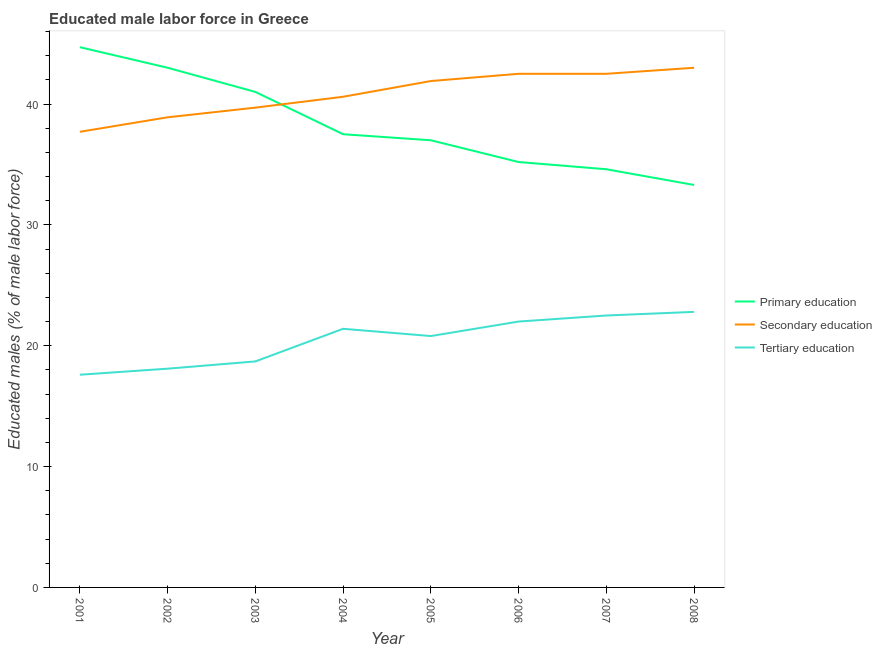What is the percentage of male labor force who received tertiary education in 2008?
Ensure brevity in your answer.  22.8. Across all years, what is the maximum percentage of male labor force who received primary education?
Offer a very short reply. 44.7. Across all years, what is the minimum percentage of male labor force who received primary education?
Your answer should be compact. 33.3. In which year was the percentage of male labor force who received primary education maximum?
Your answer should be compact. 2001. In which year was the percentage of male labor force who received primary education minimum?
Provide a short and direct response. 2008. What is the total percentage of male labor force who received tertiary education in the graph?
Make the answer very short. 163.9. What is the difference between the percentage of male labor force who received secondary education in 2001 and that in 2005?
Make the answer very short. -4.2. What is the average percentage of male labor force who received primary education per year?
Your answer should be compact. 38.29. In how many years, is the percentage of male labor force who received primary education greater than 24 %?
Make the answer very short. 8. What is the ratio of the percentage of male labor force who received secondary education in 2001 to that in 2004?
Provide a succinct answer. 0.93. Is the percentage of male labor force who received secondary education in 2001 less than that in 2008?
Keep it short and to the point. Yes. What is the difference between the highest and the lowest percentage of male labor force who received secondary education?
Provide a short and direct response. 5.3. In how many years, is the percentage of male labor force who received primary education greater than the average percentage of male labor force who received primary education taken over all years?
Make the answer very short. 3. Is the percentage of male labor force who received secondary education strictly greater than the percentage of male labor force who received tertiary education over the years?
Give a very brief answer. Yes. Is the percentage of male labor force who received secondary education strictly less than the percentage of male labor force who received primary education over the years?
Ensure brevity in your answer.  No. How many years are there in the graph?
Make the answer very short. 8. Does the graph contain any zero values?
Your response must be concise. No. How many legend labels are there?
Ensure brevity in your answer.  3. How are the legend labels stacked?
Provide a succinct answer. Vertical. What is the title of the graph?
Offer a terse response. Educated male labor force in Greece. What is the label or title of the X-axis?
Your response must be concise. Year. What is the label or title of the Y-axis?
Your answer should be compact. Educated males (% of male labor force). What is the Educated males (% of male labor force) in Primary education in 2001?
Your answer should be compact. 44.7. What is the Educated males (% of male labor force) in Secondary education in 2001?
Keep it short and to the point. 37.7. What is the Educated males (% of male labor force) of Tertiary education in 2001?
Ensure brevity in your answer.  17.6. What is the Educated males (% of male labor force) of Primary education in 2002?
Your answer should be compact. 43. What is the Educated males (% of male labor force) in Secondary education in 2002?
Provide a succinct answer. 38.9. What is the Educated males (% of male labor force) in Tertiary education in 2002?
Give a very brief answer. 18.1. What is the Educated males (% of male labor force) in Primary education in 2003?
Offer a terse response. 41. What is the Educated males (% of male labor force) in Secondary education in 2003?
Your answer should be very brief. 39.7. What is the Educated males (% of male labor force) of Tertiary education in 2003?
Provide a succinct answer. 18.7. What is the Educated males (% of male labor force) of Primary education in 2004?
Ensure brevity in your answer.  37.5. What is the Educated males (% of male labor force) of Secondary education in 2004?
Keep it short and to the point. 40.6. What is the Educated males (% of male labor force) in Tertiary education in 2004?
Offer a very short reply. 21.4. What is the Educated males (% of male labor force) in Secondary education in 2005?
Make the answer very short. 41.9. What is the Educated males (% of male labor force) in Tertiary education in 2005?
Provide a short and direct response. 20.8. What is the Educated males (% of male labor force) of Primary education in 2006?
Provide a succinct answer. 35.2. What is the Educated males (% of male labor force) in Secondary education in 2006?
Make the answer very short. 42.5. What is the Educated males (% of male labor force) in Primary education in 2007?
Offer a terse response. 34.6. What is the Educated males (% of male labor force) in Secondary education in 2007?
Your answer should be compact. 42.5. What is the Educated males (% of male labor force) of Tertiary education in 2007?
Ensure brevity in your answer.  22.5. What is the Educated males (% of male labor force) of Primary education in 2008?
Provide a short and direct response. 33.3. What is the Educated males (% of male labor force) of Secondary education in 2008?
Offer a terse response. 43. What is the Educated males (% of male labor force) of Tertiary education in 2008?
Offer a very short reply. 22.8. Across all years, what is the maximum Educated males (% of male labor force) of Primary education?
Give a very brief answer. 44.7. Across all years, what is the maximum Educated males (% of male labor force) in Tertiary education?
Your answer should be very brief. 22.8. Across all years, what is the minimum Educated males (% of male labor force) of Primary education?
Provide a succinct answer. 33.3. Across all years, what is the minimum Educated males (% of male labor force) of Secondary education?
Give a very brief answer. 37.7. Across all years, what is the minimum Educated males (% of male labor force) of Tertiary education?
Keep it short and to the point. 17.6. What is the total Educated males (% of male labor force) of Primary education in the graph?
Give a very brief answer. 306.3. What is the total Educated males (% of male labor force) of Secondary education in the graph?
Offer a terse response. 326.8. What is the total Educated males (% of male labor force) in Tertiary education in the graph?
Your answer should be compact. 163.9. What is the difference between the Educated males (% of male labor force) in Primary education in 2001 and that in 2002?
Give a very brief answer. 1.7. What is the difference between the Educated males (% of male labor force) in Secondary education in 2001 and that in 2003?
Give a very brief answer. -2. What is the difference between the Educated males (% of male labor force) of Tertiary education in 2001 and that in 2003?
Offer a terse response. -1.1. What is the difference between the Educated males (% of male labor force) in Primary education in 2001 and that in 2004?
Ensure brevity in your answer.  7.2. What is the difference between the Educated males (% of male labor force) of Secondary education in 2001 and that in 2004?
Give a very brief answer. -2.9. What is the difference between the Educated males (% of male labor force) in Tertiary education in 2001 and that in 2004?
Your answer should be very brief. -3.8. What is the difference between the Educated males (% of male labor force) of Primary education in 2001 and that in 2007?
Your answer should be compact. 10.1. What is the difference between the Educated males (% of male labor force) of Tertiary education in 2001 and that in 2007?
Ensure brevity in your answer.  -4.9. What is the difference between the Educated males (% of male labor force) in Secondary education in 2001 and that in 2008?
Give a very brief answer. -5.3. What is the difference between the Educated males (% of male labor force) in Tertiary education in 2001 and that in 2008?
Keep it short and to the point. -5.2. What is the difference between the Educated males (% of male labor force) in Primary education in 2002 and that in 2003?
Give a very brief answer. 2. What is the difference between the Educated males (% of male labor force) in Secondary education in 2002 and that in 2004?
Offer a very short reply. -1.7. What is the difference between the Educated males (% of male labor force) in Tertiary education in 2002 and that in 2004?
Offer a very short reply. -3.3. What is the difference between the Educated males (% of male labor force) of Primary education in 2002 and that in 2005?
Your answer should be compact. 6. What is the difference between the Educated males (% of male labor force) of Secondary education in 2002 and that in 2006?
Your answer should be compact. -3.6. What is the difference between the Educated males (% of male labor force) of Tertiary education in 2002 and that in 2006?
Your response must be concise. -3.9. What is the difference between the Educated males (% of male labor force) of Primary education in 2002 and that in 2007?
Ensure brevity in your answer.  8.4. What is the difference between the Educated males (% of male labor force) in Secondary education in 2002 and that in 2008?
Ensure brevity in your answer.  -4.1. What is the difference between the Educated males (% of male labor force) in Primary education in 2003 and that in 2005?
Offer a very short reply. 4. What is the difference between the Educated males (% of male labor force) of Secondary education in 2003 and that in 2005?
Offer a very short reply. -2.2. What is the difference between the Educated males (% of male labor force) in Tertiary education in 2003 and that in 2005?
Your answer should be compact. -2.1. What is the difference between the Educated males (% of male labor force) in Tertiary education in 2003 and that in 2006?
Your answer should be very brief. -3.3. What is the difference between the Educated males (% of male labor force) in Primary education in 2003 and that in 2008?
Offer a terse response. 7.7. What is the difference between the Educated males (% of male labor force) of Tertiary education in 2003 and that in 2008?
Provide a short and direct response. -4.1. What is the difference between the Educated males (% of male labor force) in Tertiary education in 2004 and that in 2005?
Provide a short and direct response. 0.6. What is the difference between the Educated males (% of male labor force) in Secondary education in 2004 and that in 2007?
Offer a very short reply. -1.9. What is the difference between the Educated males (% of male labor force) of Tertiary education in 2004 and that in 2007?
Offer a terse response. -1.1. What is the difference between the Educated males (% of male labor force) in Secondary education in 2004 and that in 2008?
Keep it short and to the point. -2.4. What is the difference between the Educated males (% of male labor force) of Primary education in 2005 and that in 2006?
Ensure brevity in your answer.  1.8. What is the difference between the Educated males (% of male labor force) in Tertiary education in 2005 and that in 2006?
Your answer should be very brief. -1.2. What is the difference between the Educated males (% of male labor force) in Primary education in 2005 and that in 2007?
Offer a terse response. 2.4. What is the difference between the Educated males (% of male labor force) in Tertiary education in 2005 and that in 2007?
Offer a very short reply. -1.7. What is the difference between the Educated males (% of male labor force) of Primary education in 2005 and that in 2008?
Keep it short and to the point. 3.7. What is the difference between the Educated males (% of male labor force) in Tertiary education in 2005 and that in 2008?
Your answer should be very brief. -2. What is the difference between the Educated males (% of male labor force) of Primary education in 2006 and that in 2007?
Provide a succinct answer. 0.6. What is the difference between the Educated males (% of male labor force) in Secondary education in 2006 and that in 2008?
Provide a short and direct response. -0.5. What is the difference between the Educated males (% of male labor force) of Primary education in 2007 and that in 2008?
Your answer should be compact. 1.3. What is the difference between the Educated males (% of male labor force) of Tertiary education in 2007 and that in 2008?
Offer a very short reply. -0.3. What is the difference between the Educated males (% of male labor force) in Primary education in 2001 and the Educated males (% of male labor force) in Secondary education in 2002?
Your answer should be compact. 5.8. What is the difference between the Educated males (% of male labor force) in Primary education in 2001 and the Educated males (% of male labor force) in Tertiary education in 2002?
Keep it short and to the point. 26.6. What is the difference between the Educated males (% of male labor force) in Secondary education in 2001 and the Educated males (% of male labor force) in Tertiary education in 2002?
Ensure brevity in your answer.  19.6. What is the difference between the Educated males (% of male labor force) of Primary education in 2001 and the Educated males (% of male labor force) of Tertiary education in 2003?
Offer a terse response. 26. What is the difference between the Educated males (% of male labor force) of Secondary education in 2001 and the Educated males (% of male labor force) of Tertiary education in 2003?
Offer a very short reply. 19. What is the difference between the Educated males (% of male labor force) in Primary education in 2001 and the Educated males (% of male labor force) in Secondary education in 2004?
Provide a succinct answer. 4.1. What is the difference between the Educated males (% of male labor force) in Primary education in 2001 and the Educated males (% of male labor force) in Tertiary education in 2004?
Give a very brief answer. 23.3. What is the difference between the Educated males (% of male labor force) of Primary education in 2001 and the Educated males (% of male labor force) of Secondary education in 2005?
Provide a succinct answer. 2.8. What is the difference between the Educated males (% of male labor force) of Primary education in 2001 and the Educated males (% of male labor force) of Tertiary education in 2005?
Your answer should be compact. 23.9. What is the difference between the Educated males (% of male labor force) of Secondary education in 2001 and the Educated males (% of male labor force) of Tertiary education in 2005?
Offer a terse response. 16.9. What is the difference between the Educated males (% of male labor force) of Primary education in 2001 and the Educated males (% of male labor force) of Secondary education in 2006?
Your answer should be compact. 2.2. What is the difference between the Educated males (% of male labor force) in Primary education in 2001 and the Educated males (% of male labor force) in Tertiary education in 2006?
Your answer should be compact. 22.7. What is the difference between the Educated males (% of male labor force) in Secondary education in 2001 and the Educated males (% of male labor force) in Tertiary education in 2006?
Your response must be concise. 15.7. What is the difference between the Educated males (% of male labor force) of Primary education in 2001 and the Educated males (% of male labor force) of Secondary education in 2007?
Keep it short and to the point. 2.2. What is the difference between the Educated males (% of male labor force) of Primary education in 2001 and the Educated males (% of male labor force) of Tertiary education in 2007?
Offer a very short reply. 22.2. What is the difference between the Educated males (% of male labor force) of Secondary education in 2001 and the Educated males (% of male labor force) of Tertiary education in 2007?
Offer a terse response. 15.2. What is the difference between the Educated males (% of male labor force) of Primary education in 2001 and the Educated males (% of male labor force) of Tertiary education in 2008?
Your answer should be very brief. 21.9. What is the difference between the Educated males (% of male labor force) of Secondary education in 2001 and the Educated males (% of male labor force) of Tertiary education in 2008?
Give a very brief answer. 14.9. What is the difference between the Educated males (% of male labor force) in Primary education in 2002 and the Educated males (% of male labor force) in Tertiary education in 2003?
Keep it short and to the point. 24.3. What is the difference between the Educated males (% of male labor force) in Secondary education in 2002 and the Educated males (% of male labor force) in Tertiary education in 2003?
Offer a very short reply. 20.2. What is the difference between the Educated males (% of male labor force) in Primary education in 2002 and the Educated males (% of male labor force) in Tertiary education in 2004?
Your answer should be very brief. 21.6. What is the difference between the Educated males (% of male labor force) in Secondary education in 2002 and the Educated males (% of male labor force) in Tertiary education in 2004?
Keep it short and to the point. 17.5. What is the difference between the Educated males (% of male labor force) in Primary education in 2002 and the Educated males (% of male labor force) in Secondary education in 2005?
Offer a terse response. 1.1. What is the difference between the Educated males (% of male labor force) of Primary education in 2002 and the Educated males (% of male labor force) of Tertiary education in 2005?
Give a very brief answer. 22.2. What is the difference between the Educated males (% of male labor force) of Primary education in 2002 and the Educated males (% of male labor force) of Secondary education in 2006?
Your answer should be compact. 0.5. What is the difference between the Educated males (% of male labor force) in Primary education in 2002 and the Educated males (% of male labor force) in Tertiary education in 2006?
Your response must be concise. 21. What is the difference between the Educated males (% of male labor force) in Secondary education in 2002 and the Educated males (% of male labor force) in Tertiary education in 2006?
Provide a succinct answer. 16.9. What is the difference between the Educated males (% of male labor force) in Secondary education in 2002 and the Educated males (% of male labor force) in Tertiary education in 2007?
Give a very brief answer. 16.4. What is the difference between the Educated males (% of male labor force) of Primary education in 2002 and the Educated males (% of male labor force) of Tertiary education in 2008?
Make the answer very short. 20.2. What is the difference between the Educated males (% of male labor force) in Secondary education in 2002 and the Educated males (% of male labor force) in Tertiary education in 2008?
Provide a short and direct response. 16.1. What is the difference between the Educated males (% of male labor force) in Primary education in 2003 and the Educated males (% of male labor force) in Secondary education in 2004?
Make the answer very short. 0.4. What is the difference between the Educated males (% of male labor force) in Primary education in 2003 and the Educated males (% of male labor force) in Tertiary education in 2004?
Ensure brevity in your answer.  19.6. What is the difference between the Educated males (% of male labor force) of Primary education in 2003 and the Educated males (% of male labor force) of Secondary education in 2005?
Your answer should be very brief. -0.9. What is the difference between the Educated males (% of male labor force) in Primary education in 2003 and the Educated males (% of male labor force) in Tertiary education in 2005?
Make the answer very short. 20.2. What is the difference between the Educated males (% of male labor force) of Secondary education in 2003 and the Educated males (% of male labor force) of Tertiary education in 2005?
Offer a terse response. 18.9. What is the difference between the Educated males (% of male labor force) in Primary education in 2003 and the Educated males (% of male labor force) in Secondary education in 2006?
Provide a short and direct response. -1.5. What is the difference between the Educated males (% of male labor force) in Primary education in 2003 and the Educated males (% of male labor force) in Tertiary education in 2006?
Make the answer very short. 19. What is the difference between the Educated males (% of male labor force) of Secondary education in 2003 and the Educated males (% of male labor force) of Tertiary education in 2006?
Ensure brevity in your answer.  17.7. What is the difference between the Educated males (% of male labor force) of Primary education in 2003 and the Educated males (% of male labor force) of Secondary education in 2007?
Offer a terse response. -1.5. What is the difference between the Educated males (% of male labor force) of Secondary education in 2003 and the Educated males (% of male labor force) of Tertiary education in 2007?
Give a very brief answer. 17.2. What is the difference between the Educated males (% of male labor force) of Secondary education in 2003 and the Educated males (% of male labor force) of Tertiary education in 2008?
Offer a very short reply. 16.9. What is the difference between the Educated males (% of male labor force) in Primary education in 2004 and the Educated males (% of male labor force) in Secondary education in 2005?
Your answer should be compact. -4.4. What is the difference between the Educated males (% of male labor force) in Primary education in 2004 and the Educated males (% of male labor force) in Tertiary education in 2005?
Your answer should be compact. 16.7. What is the difference between the Educated males (% of male labor force) of Secondary education in 2004 and the Educated males (% of male labor force) of Tertiary education in 2005?
Provide a short and direct response. 19.8. What is the difference between the Educated males (% of male labor force) in Primary education in 2004 and the Educated males (% of male labor force) in Secondary education in 2006?
Give a very brief answer. -5. What is the difference between the Educated males (% of male labor force) in Primary education in 2005 and the Educated males (% of male labor force) in Tertiary education in 2008?
Provide a short and direct response. 14.2. What is the difference between the Educated males (% of male labor force) of Primary education in 2006 and the Educated males (% of male labor force) of Tertiary education in 2007?
Your response must be concise. 12.7. What is the difference between the Educated males (% of male labor force) in Primary education in 2006 and the Educated males (% of male labor force) in Tertiary education in 2008?
Make the answer very short. 12.4. What is the difference between the Educated males (% of male labor force) of Secondary education in 2006 and the Educated males (% of male labor force) of Tertiary education in 2008?
Provide a succinct answer. 19.7. What is the difference between the Educated males (% of male labor force) of Primary education in 2007 and the Educated males (% of male labor force) of Secondary education in 2008?
Ensure brevity in your answer.  -8.4. What is the difference between the Educated males (% of male labor force) in Primary education in 2007 and the Educated males (% of male labor force) in Tertiary education in 2008?
Offer a very short reply. 11.8. What is the difference between the Educated males (% of male labor force) in Secondary education in 2007 and the Educated males (% of male labor force) in Tertiary education in 2008?
Make the answer very short. 19.7. What is the average Educated males (% of male labor force) of Primary education per year?
Provide a succinct answer. 38.29. What is the average Educated males (% of male labor force) of Secondary education per year?
Your answer should be compact. 40.85. What is the average Educated males (% of male labor force) in Tertiary education per year?
Your response must be concise. 20.49. In the year 2001, what is the difference between the Educated males (% of male labor force) in Primary education and Educated males (% of male labor force) in Tertiary education?
Keep it short and to the point. 27.1. In the year 2001, what is the difference between the Educated males (% of male labor force) in Secondary education and Educated males (% of male labor force) in Tertiary education?
Offer a very short reply. 20.1. In the year 2002, what is the difference between the Educated males (% of male labor force) in Primary education and Educated males (% of male labor force) in Tertiary education?
Ensure brevity in your answer.  24.9. In the year 2002, what is the difference between the Educated males (% of male labor force) in Secondary education and Educated males (% of male labor force) in Tertiary education?
Provide a succinct answer. 20.8. In the year 2003, what is the difference between the Educated males (% of male labor force) in Primary education and Educated males (% of male labor force) in Secondary education?
Offer a terse response. 1.3. In the year 2003, what is the difference between the Educated males (% of male labor force) of Primary education and Educated males (% of male labor force) of Tertiary education?
Your answer should be compact. 22.3. In the year 2003, what is the difference between the Educated males (% of male labor force) in Secondary education and Educated males (% of male labor force) in Tertiary education?
Offer a terse response. 21. In the year 2004, what is the difference between the Educated males (% of male labor force) in Primary education and Educated males (% of male labor force) in Tertiary education?
Provide a succinct answer. 16.1. In the year 2005, what is the difference between the Educated males (% of male labor force) in Primary education and Educated males (% of male labor force) in Secondary education?
Keep it short and to the point. -4.9. In the year 2005, what is the difference between the Educated males (% of male labor force) in Primary education and Educated males (% of male labor force) in Tertiary education?
Make the answer very short. 16.2. In the year 2005, what is the difference between the Educated males (% of male labor force) of Secondary education and Educated males (% of male labor force) of Tertiary education?
Your response must be concise. 21.1. In the year 2006, what is the difference between the Educated males (% of male labor force) of Primary education and Educated males (% of male labor force) of Secondary education?
Provide a short and direct response. -7.3. In the year 2006, what is the difference between the Educated males (% of male labor force) of Primary education and Educated males (% of male labor force) of Tertiary education?
Give a very brief answer. 13.2. In the year 2006, what is the difference between the Educated males (% of male labor force) in Secondary education and Educated males (% of male labor force) in Tertiary education?
Your answer should be very brief. 20.5. In the year 2007, what is the difference between the Educated males (% of male labor force) of Primary education and Educated males (% of male labor force) of Secondary education?
Offer a terse response. -7.9. In the year 2007, what is the difference between the Educated males (% of male labor force) of Primary education and Educated males (% of male labor force) of Tertiary education?
Your answer should be very brief. 12.1. In the year 2008, what is the difference between the Educated males (% of male labor force) in Primary education and Educated males (% of male labor force) in Tertiary education?
Give a very brief answer. 10.5. In the year 2008, what is the difference between the Educated males (% of male labor force) of Secondary education and Educated males (% of male labor force) of Tertiary education?
Ensure brevity in your answer.  20.2. What is the ratio of the Educated males (% of male labor force) of Primary education in 2001 to that in 2002?
Offer a very short reply. 1.04. What is the ratio of the Educated males (% of male labor force) of Secondary education in 2001 to that in 2002?
Give a very brief answer. 0.97. What is the ratio of the Educated males (% of male labor force) in Tertiary education in 2001 to that in 2002?
Offer a terse response. 0.97. What is the ratio of the Educated males (% of male labor force) of Primary education in 2001 to that in 2003?
Offer a terse response. 1.09. What is the ratio of the Educated males (% of male labor force) of Secondary education in 2001 to that in 2003?
Provide a short and direct response. 0.95. What is the ratio of the Educated males (% of male labor force) of Primary education in 2001 to that in 2004?
Your answer should be very brief. 1.19. What is the ratio of the Educated males (% of male labor force) of Secondary education in 2001 to that in 2004?
Keep it short and to the point. 0.93. What is the ratio of the Educated males (% of male labor force) in Tertiary education in 2001 to that in 2004?
Provide a short and direct response. 0.82. What is the ratio of the Educated males (% of male labor force) of Primary education in 2001 to that in 2005?
Ensure brevity in your answer.  1.21. What is the ratio of the Educated males (% of male labor force) of Secondary education in 2001 to that in 2005?
Provide a short and direct response. 0.9. What is the ratio of the Educated males (% of male labor force) in Tertiary education in 2001 to that in 2005?
Offer a terse response. 0.85. What is the ratio of the Educated males (% of male labor force) in Primary education in 2001 to that in 2006?
Give a very brief answer. 1.27. What is the ratio of the Educated males (% of male labor force) of Secondary education in 2001 to that in 2006?
Provide a short and direct response. 0.89. What is the ratio of the Educated males (% of male labor force) of Tertiary education in 2001 to that in 2006?
Provide a short and direct response. 0.8. What is the ratio of the Educated males (% of male labor force) in Primary education in 2001 to that in 2007?
Keep it short and to the point. 1.29. What is the ratio of the Educated males (% of male labor force) of Secondary education in 2001 to that in 2007?
Ensure brevity in your answer.  0.89. What is the ratio of the Educated males (% of male labor force) in Tertiary education in 2001 to that in 2007?
Offer a very short reply. 0.78. What is the ratio of the Educated males (% of male labor force) in Primary education in 2001 to that in 2008?
Offer a terse response. 1.34. What is the ratio of the Educated males (% of male labor force) in Secondary education in 2001 to that in 2008?
Provide a short and direct response. 0.88. What is the ratio of the Educated males (% of male labor force) of Tertiary education in 2001 to that in 2008?
Give a very brief answer. 0.77. What is the ratio of the Educated males (% of male labor force) of Primary education in 2002 to that in 2003?
Your answer should be very brief. 1.05. What is the ratio of the Educated males (% of male labor force) of Secondary education in 2002 to that in 2003?
Give a very brief answer. 0.98. What is the ratio of the Educated males (% of male labor force) of Tertiary education in 2002 to that in 2003?
Offer a very short reply. 0.97. What is the ratio of the Educated males (% of male labor force) of Primary education in 2002 to that in 2004?
Give a very brief answer. 1.15. What is the ratio of the Educated males (% of male labor force) in Secondary education in 2002 to that in 2004?
Your response must be concise. 0.96. What is the ratio of the Educated males (% of male labor force) of Tertiary education in 2002 to that in 2004?
Offer a very short reply. 0.85. What is the ratio of the Educated males (% of male labor force) in Primary education in 2002 to that in 2005?
Make the answer very short. 1.16. What is the ratio of the Educated males (% of male labor force) in Secondary education in 2002 to that in 2005?
Make the answer very short. 0.93. What is the ratio of the Educated males (% of male labor force) in Tertiary education in 2002 to that in 2005?
Ensure brevity in your answer.  0.87. What is the ratio of the Educated males (% of male labor force) of Primary education in 2002 to that in 2006?
Give a very brief answer. 1.22. What is the ratio of the Educated males (% of male labor force) of Secondary education in 2002 to that in 2006?
Offer a terse response. 0.92. What is the ratio of the Educated males (% of male labor force) of Tertiary education in 2002 to that in 2006?
Offer a terse response. 0.82. What is the ratio of the Educated males (% of male labor force) in Primary education in 2002 to that in 2007?
Your answer should be very brief. 1.24. What is the ratio of the Educated males (% of male labor force) of Secondary education in 2002 to that in 2007?
Provide a short and direct response. 0.92. What is the ratio of the Educated males (% of male labor force) in Tertiary education in 2002 to that in 2007?
Your answer should be very brief. 0.8. What is the ratio of the Educated males (% of male labor force) in Primary education in 2002 to that in 2008?
Offer a terse response. 1.29. What is the ratio of the Educated males (% of male labor force) of Secondary education in 2002 to that in 2008?
Make the answer very short. 0.9. What is the ratio of the Educated males (% of male labor force) of Tertiary education in 2002 to that in 2008?
Your answer should be very brief. 0.79. What is the ratio of the Educated males (% of male labor force) of Primary education in 2003 to that in 2004?
Your answer should be compact. 1.09. What is the ratio of the Educated males (% of male labor force) in Secondary education in 2003 to that in 2004?
Ensure brevity in your answer.  0.98. What is the ratio of the Educated males (% of male labor force) in Tertiary education in 2003 to that in 2004?
Your answer should be compact. 0.87. What is the ratio of the Educated males (% of male labor force) of Primary education in 2003 to that in 2005?
Provide a short and direct response. 1.11. What is the ratio of the Educated males (% of male labor force) of Secondary education in 2003 to that in 2005?
Make the answer very short. 0.95. What is the ratio of the Educated males (% of male labor force) in Tertiary education in 2003 to that in 2005?
Your answer should be very brief. 0.9. What is the ratio of the Educated males (% of male labor force) of Primary education in 2003 to that in 2006?
Keep it short and to the point. 1.16. What is the ratio of the Educated males (% of male labor force) in Secondary education in 2003 to that in 2006?
Keep it short and to the point. 0.93. What is the ratio of the Educated males (% of male labor force) in Tertiary education in 2003 to that in 2006?
Provide a succinct answer. 0.85. What is the ratio of the Educated males (% of male labor force) of Primary education in 2003 to that in 2007?
Give a very brief answer. 1.19. What is the ratio of the Educated males (% of male labor force) in Secondary education in 2003 to that in 2007?
Your response must be concise. 0.93. What is the ratio of the Educated males (% of male labor force) of Tertiary education in 2003 to that in 2007?
Provide a short and direct response. 0.83. What is the ratio of the Educated males (% of male labor force) of Primary education in 2003 to that in 2008?
Give a very brief answer. 1.23. What is the ratio of the Educated males (% of male labor force) in Secondary education in 2003 to that in 2008?
Offer a terse response. 0.92. What is the ratio of the Educated males (% of male labor force) in Tertiary education in 2003 to that in 2008?
Provide a short and direct response. 0.82. What is the ratio of the Educated males (% of male labor force) in Primary education in 2004 to that in 2005?
Your answer should be very brief. 1.01. What is the ratio of the Educated males (% of male labor force) in Tertiary education in 2004 to that in 2005?
Your answer should be compact. 1.03. What is the ratio of the Educated males (% of male labor force) in Primary education in 2004 to that in 2006?
Offer a very short reply. 1.07. What is the ratio of the Educated males (% of male labor force) of Secondary education in 2004 to that in 2006?
Offer a very short reply. 0.96. What is the ratio of the Educated males (% of male labor force) in Tertiary education in 2004 to that in 2006?
Your response must be concise. 0.97. What is the ratio of the Educated males (% of male labor force) in Primary education in 2004 to that in 2007?
Your answer should be compact. 1.08. What is the ratio of the Educated males (% of male labor force) of Secondary education in 2004 to that in 2007?
Keep it short and to the point. 0.96. What is the ratio of the Educated males (% of male labor force) in Tertiary education in 2004 to that in 2007?
Offer a very short reply. 0.95. What is the ratio of the Educated males (% of male labor force) in Primary education in 2004 to that in 2008?
Your response must be concise. 1.13. What is the ratio of the Educated males (% of male labor force) of Secondary education in 2004 to that in 2008?
Your answer should be very brief. 0.94. What is the ratio of the Educated males (% of male labor force) of Tertiary education in 2004 to that in 2008?
Your answer should be compact. 0.94. What is the ratio of the Educated males (% of male labor force) of Primary education in 2005 to that in 2006?
Provide a succinct answer. 1.05. What is the ratio of the Educated males (% of male labor force) of Secondary education in 2005 to that in 2006?
Offer a terse response. 0.99. What is the ratio of the Educated males (% of male labor force) in Tertiary education in 2005 to that in 2006?
Provide a succinct answer. 0.95. What is the ratio of the Educated males (% of male labor force) in Primary education in 2005 to that in 2007?
Your answer should be very brief. 1.07. What is the ratio of the Educated males (% of male labor force) of Secondary education in 2005 to that in 2007?
Your answer should be very brief. 0.99. What is the ratio of the Educated males (% of male labor force) of Tertiary education in 2005 to that in 2007?
Ensure brevity in your answer.  0.92. What is the ratio of the Educated males (% of male labor force) in Secondary education in 2005 to that in 2008?
Ensure brevity in your answer.  0.97. What is the ratio of the Educated males (% of male labor force) of Tertiary education in 2005 to that in 2008?
Ensure brevity in your answer.  0.91. What is the ratio of the Educated males (% of male labor force) of Primary education in 2006 to that in 2007?
Offer a terse response. 1.02. What is the ratio of the Educated males (% of male labor force) of Secondary education in 2006 to that in 2007?
Offer a terse response. 1. What is the ratio of the Educated males (% of male labor force) in Tertiary education in 2006 to that in 2007?
Your response must be concise. 0.98. What is the ratio of the Educated males (% of male labor force) in Primary education in 2006 to that in 2008?
Give a very brief answer. 1.06. What is the ratio of the Educated males (% of male labor force) in Secondary education in 2006 to that in 2008?
Your answer should be compact. 0.99. What is the ratio of the Educated males (% of male labor force) of Tertiary education in 2006 to that in 2008?
Keep it short and to the point. 0.96. What is the ratio of the Educated males (% of male labor force) of Primary education in 2007 to that in 2008?
Provide a succinct answer. 1.04. What is the ratio of the Educated males (% of male labor force) of Secondary education in 2007 to that in 2008?
Your answer should be compact. 0.99. What is the difference between the highest and the second highest Educated males (% of male labor force) in Primary education?
Your response must be concise. 1.7. What is the difference between the highest and the second highest Educated males (% of male labor force) of Tertiary education?
Provide a short and direct response. 0.3. What is the difference between the highest and the lowest Educated males (% of male labor force) of Tertiary education?
Offer a terse response. 5.2. 